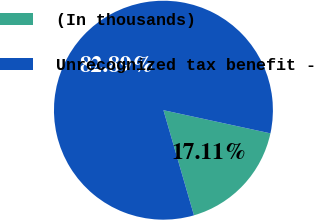<chart> <loc_0><loc_0><loc_500><loc_500><pie_chart><fcel>(In thousands)<fcel>Unrecognized tax benefit -<nl><fcel>17.11%<fcel>82.89%<nl></chart> 